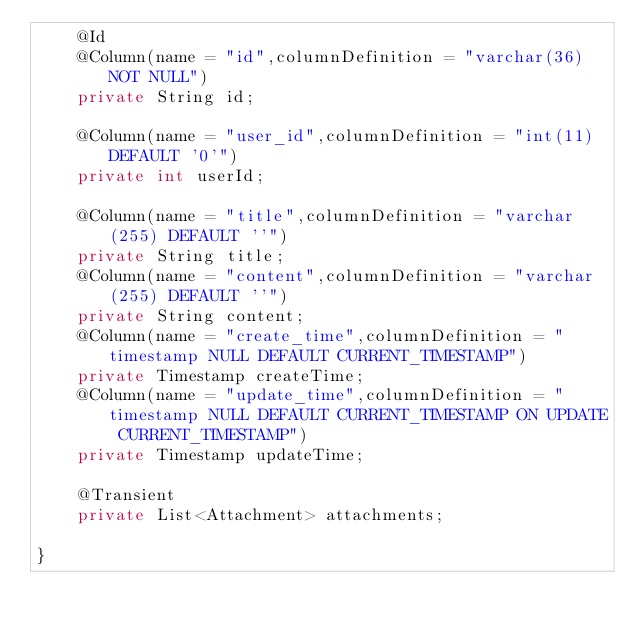Convert code to text. <code><loc_0><loc_0><loc_500><loc_500><_Java_>    @Id
    @Column(name = "id",columnDefinition = "varchar(36) NOT NULL")
    private String id;

    @Column(name = "user_id",columnDefinition = "int(11) DEFAULT '0'")
    private int userId;

    @Column(name = "title",columnDefinition = "varchar(255) DEFAULT ''")
    private String title;
    @Column(name = "content",columnDefinition = "varchar(255) DEFAULT ''")
    private String content;
    @Column(name = "create_time",columnDefinition = "timestamp NULL DEFAULT CURRENT_TIMESTAMP")
    private Timestamp createTime;
    @Column(name = "update_time",columnDefinition = "timestamp NULL DEFAULT CURRENT_TIMESTAMP ON UPDATE CURRENT_TIMESTAMP")
    private Timestamp updateTime;

    @Transient
    private List<Attachment> attachments;

}
</code> 